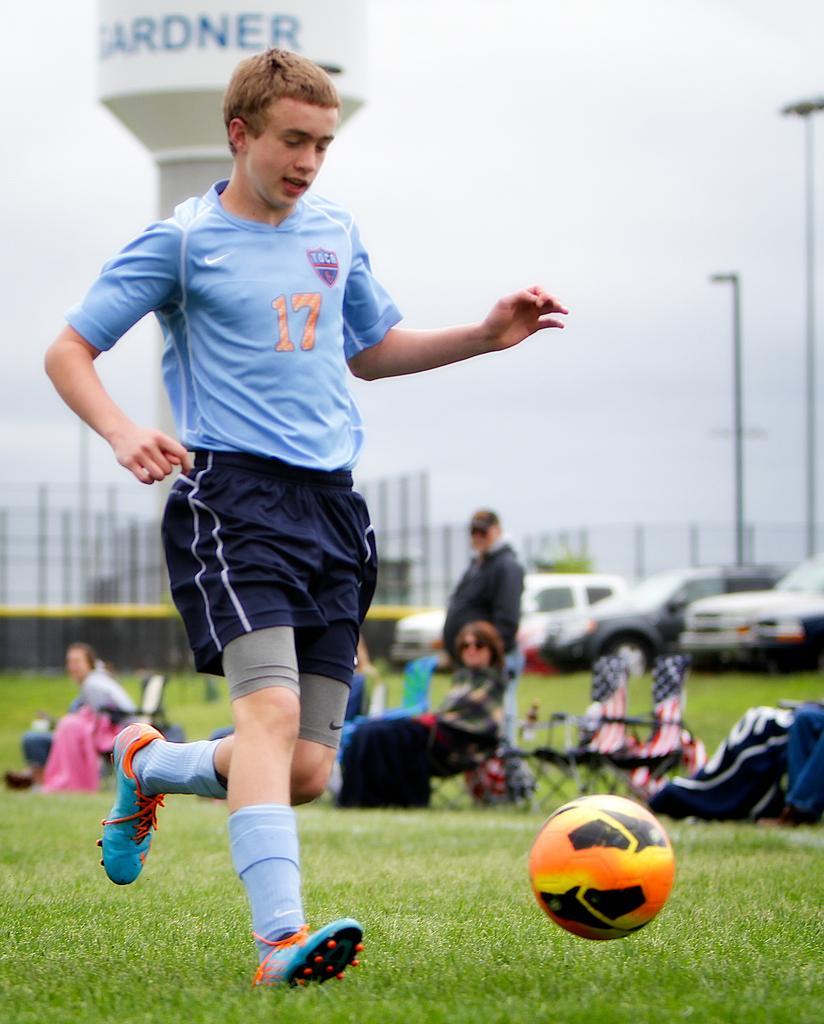In one or two sentences, can you explain what this image depicts? In this picture we can see a man wearing sports dress running, there is a ball and in the background of the picture there are some persons sitting on chairs, there are some vehicles which are parked and we can see water tank, poles. 